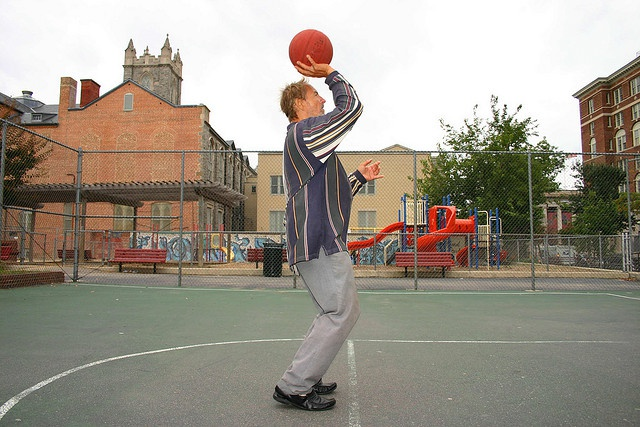Describe the objects in this image and their specific colors. I can see people in white, gray, darkgray, and black tones, sports ball in white, brown, and salmon tones, bench in white, brown, maroon, and gray tones, bench in white, brown, maroon, and black tones, and truck in white, gray, darkgray, and black tones in this image. 